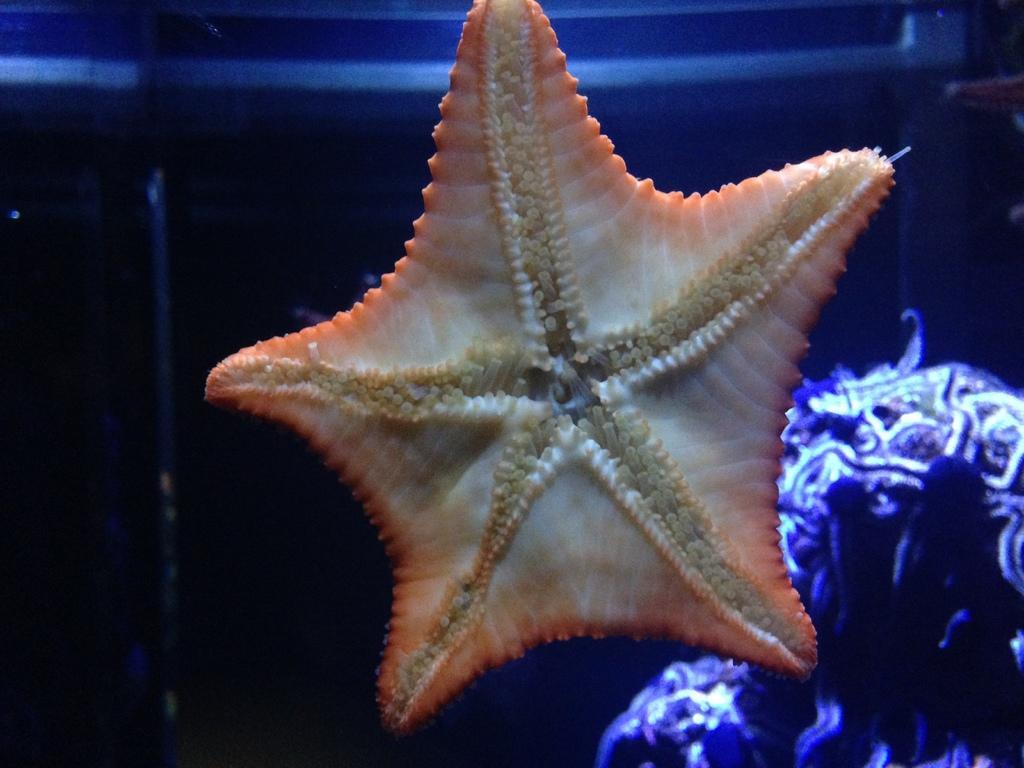In one or two sentences, can you explain what this image depicts? In this image there is a starfish at the middle of image. Right bottom there is an aquatic animal in the water. 